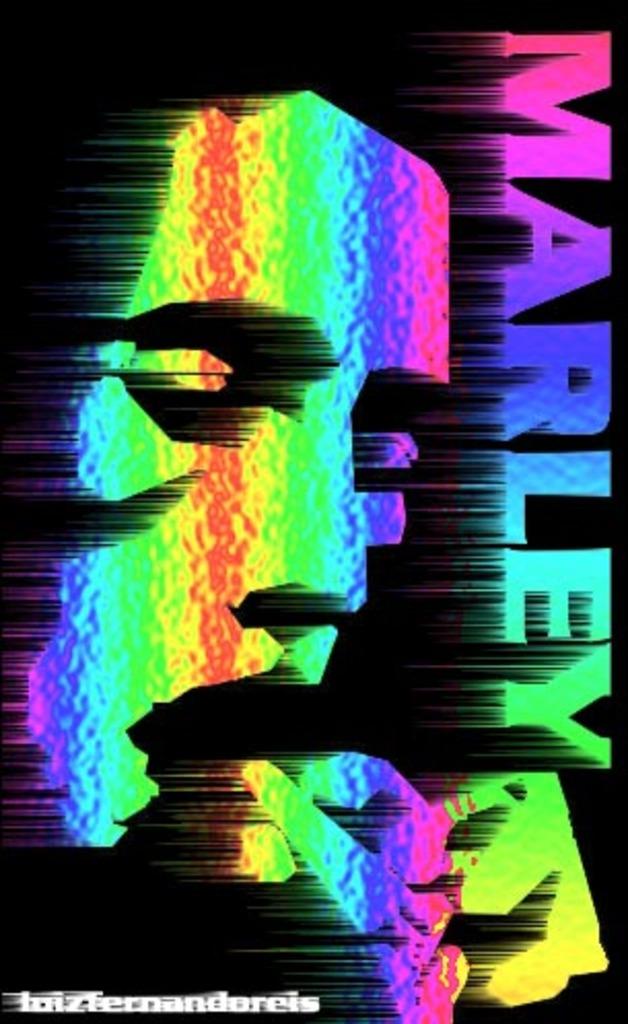What is the name in color on this poster?
Offer a very short reply. Marley. 